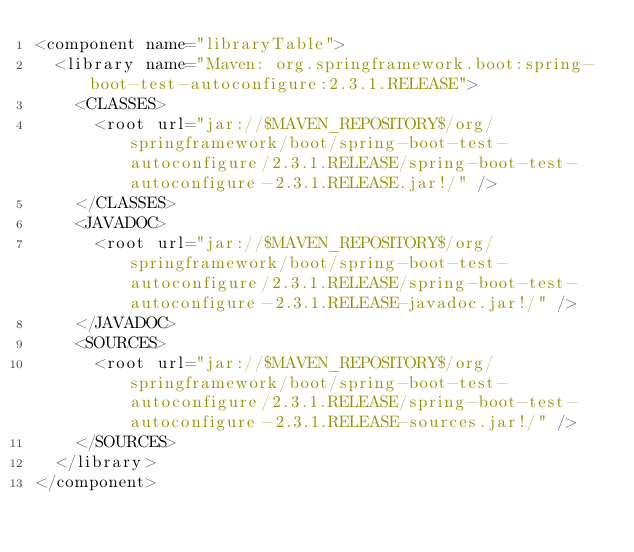Convert code to text. <code><loc_0><loc_0><loc_500><loc_500><_XML_><component name="libraryTable">
  <library name="Maven: org.springframework.boot:spring-boot-test-autoconfigure:2.3.1.RELEASE">
    <CLASSES>
      <root url="jar://$MAVEN_REPOSITORY$/org/springframework/boot/spring-boot-test-autoconfigure/2.3.1.RELEASE/spring-boot-test-autoconfigure-2.3.1.RELEASE.jar!/" />
    </CLASSES>
    <JAVADOC>
      <root url="jar://$MAVEN_REPOSITORY$/org/springframework/boot/spring-boot-test-autoconfigure/2.3.1.RELEASE/spring-boot-test-autoconfigure-2.3.1.RELEASE-javadoc.jar!/" />
    </JAVADOC>
    <SOURCES>
      <root url="jar://$MAVEN_REPOSITORY$/org/springframework/boot/spring-boot-test-autoconfigure/2.3.1.RELEASE/spring-boot-test-autoconfigure-2.3.1.RELEASE-sources.jar!/" />
    </SOURCES>
  </library>
</component></code> 